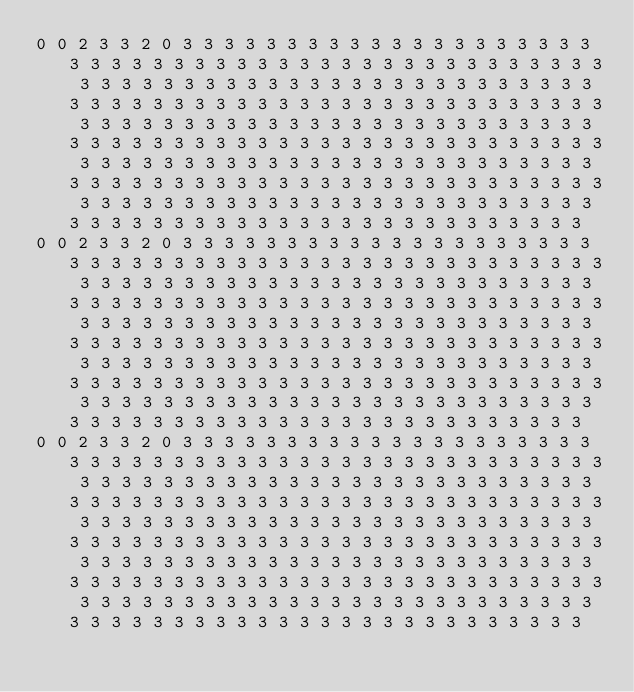<code> <loc_0><loc_0><loc_500><loc_500><_Crystal_>0 0 2 3 3 2 0 3 3 3 3 3 3 3 3 3 3 3 3 3 3 3 3 3 3 3 3 3 3 3 3 3 3 3 3 3 3 3 3 3 3 3 3 3 3 3 3 3 3 3 3 3 3 3 3 3 3 3 3 3 3 3 3 3 3 3 3 3 3 3 3 3 3 3 3 3 3 3 3 3 3 3 3 3 3 3 3 3 3 3 3 3 3 3 3 3 3 3 3 3 3 3 3 3 3 3 3 3 3 3 3 3 3 3 3 3 3 3 3 3 3 3 3 3 3 3 3 3 3 3 3 3 3 3 3 3 3 3 3 3 3 3 3 3 3 3 3 3 3 3 3 3 3 3 3 3 3 3 3 3 3 3 3 3 3 3 3 3 3 3 3 3 3 3 3 3 3 3 3 3 3 3 3 3 3 3 3 3 3 3 3 3 3 3 3 3 3 3 3 3 3 3 3 3 3 3 3 3 3 3 3 3 3 3 3 3 3 3 3 3 3 3 3 3 3 3 3 3 3 3 3 3 3 3 3 3 3 3 3 3 3 3 3 3 3 3 3 3 3 3 3 3 3 3 3 3 
0 0 2 3 3 2 0 3 3 3 3 3 3 3 3 3 3 3 3 3 3 3 3 3 3 3 3 3 3 3 3 3 3 3 3 3 3 3 3 3 3 3 3 3 3 3 3 3 3 3 3 3 3 3 3 3 3 3 3 3 3 3 3 3 3 3 3 3 3 3 3 3 3 3 3 3 3 3 3 3 3 3 3 3 3 3 3 3 3 3 3 3 3 3 3 3 3 3 3 3 3 3 3 3 3 3 3 3 3 3 3 3 3 3 3 3 3 3 3 3 3 3 3 3 3 3 3 3 3 3 3 3 3 3 3 3 3 3 3 3 3 3 3 3 3 3 3 3 3 3 3 3 3 3 3 3 3 3 3 3 3 3 3 3 3 3 3 3 3 3 3 3 3 3 3 3 3 3 3 3 3 3 3 3 3 3 3 3 3 3 3 3 3 3 3 3 3 3 3 3 3 3 3 3 3 3 3 3 3 3 3 3 3 3 3 3 3 3 3 3 3 3 3 3 3 3 3 3 3 3 3 3 3 3 3 3 3 3 3 3 3 3 3 3 3 3 3 3 3 3 3 3 3 3 3 3 
0 0 2 3 3 2 0 3 3 3 3 3 3 3 3 3 3 3 3 3 3 3 3 3 3 3 3 3 3 3 3 3 3 3 3 3 3 3 3 3 3 3 3 3 3 3 3 3 3 3 3 3 3 3 3 3 3 3 3 3 3 3 3 3 3 3 3 3 3 3 3 3 3 3 3 3 3 3 3 3 3 3 3 3 3 3 3 3 3 3 3 3 3 3 3 3 3 3 3 3 3 3 3 3 3 3 3 3 3 3 3 3 3 3 3 3 3 3 3 3 3 3 3 3 3 3 3 3 3 3 3 3 3 3 3 3 3 3 3 3 3 3 3 3 3 3 3 3 3 3 3 3 3 3 3 3 3 3 3 3 3 3 3 3 3 3 3 3 3 3 3 3 3 3 3 3 3 3 3 3 3 3 3 3 3 3 3 3 3 3 3 3 3 3 3 3 3 3 3 3 3 3 3 3 3 3 3 3 3 3 3 3 3 3 3 3 3 3 3 3 3 3 3 3 3 3 3 3 3 3 3 3 3 3 3 3 3 3 3 3 3 3 3 3 3 3 3 3 3 3 3 3 3 3 3 3 </code> 